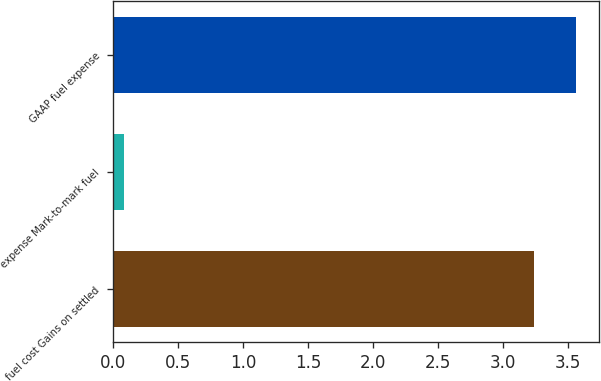<chart> <loc_0><loc_0><loc_500><loc_500><bar_chart><fcel>fuel cost Gains on settled<fcel>expense Mark-to-mark fuel<fcel>GAAP fuel expense<nl><fcel>3.24<fcel>0.08<fcel>3.56<nl></chart> 